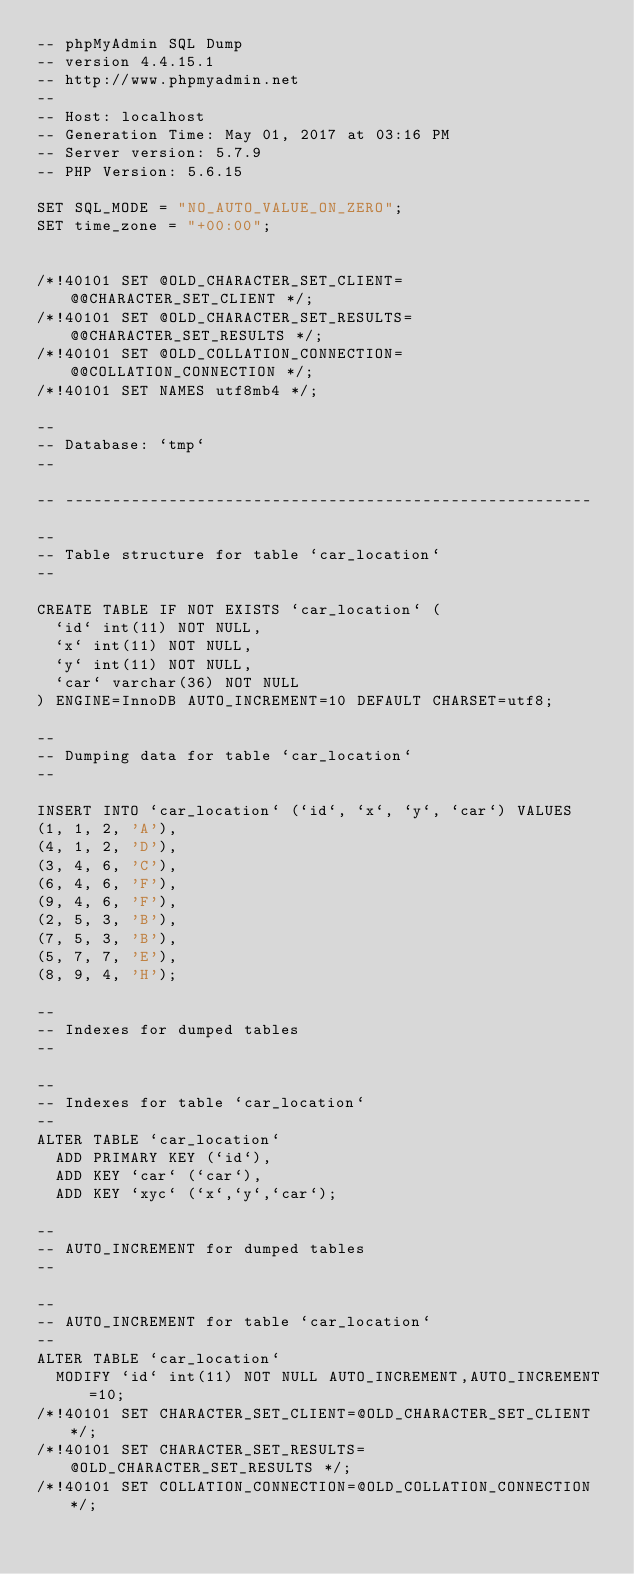<code> <loc_0><loc_0><loc_500><loc_500><_SQL_>-- phpMyAdmin SQL Dump
-- version 4.4.15.1
-- http://www.phpmyadmin.net
--
-- Host: localhost
-- Generation Time: May 01, 2017 at 03:16 PM
-- Server version: 5.7.9
-- PHP Version: 5.6.15

SET SQL_MODE = "NO_AUTO_VALUE_ON_ZERO";
SET time_zone = "+00:00";


/*!40101 SET @OLD_CHARACTER_SET_CLIENT=@@CHARACTER_SET_CLIENT */;
/*!40101 SET @OLD_CHARACTER_SET_RESULTS=@@CHARACTER_SET_RESULTS */;
/*!40101 SET @OLD_COLLATION_CONNECTION=@@COLLATION_CONNECTION */;
/*!40101 SET NAMES utf8mb4 */;

--
-- Database: `tmp`
--

-- --------------------------------------------------------

--
-- Table structure for table `car_location`
--

CREATE TABLE IF NOT EXISTS `car_location` (
  `id` int(11) NOT NULL,
  `x` int(11) NOT NULL,
  `y` int(11) NOT NULL,
  `car` varchar(36) NOT NULL
) ENGINE=InnoDB AUTO_INCREMENT=10 DEFAULT CHARSET=utf8;

--
-- Dumping data for table `car_location`
--

INSERT INTO `car_location` (`id`, `x`, `y`, `car`) VALUES
(1, 1, 2, 'A'),
(4, 1, 2, 'D'),
(3, 4, 6, 'C'),
(6, 4, 6, 'F'),
(9, 4, 6, 'F'),
(2, 5, 3, 'B'),
(7, 5, 3, 'B'),
(5, 7, 7, 'E'),
(8, 9, 4, 'H');

--
-- Indexes for dumped tables
--

--
-- Indexes for table `car_location`
--
ALTER TABLE `car_location`
  ADD PRIMARY KEY (`id`),
  ADD KEY `car` (`car`),
  ADD KEY `xyc` (`x`,`y`,`car`);

--
-- AUTO_INCREMENT for dumped tables
--

--
-- AUTO_INCREMENT for table `car_location`
--
ALTER TABLE `car_location`
  MODIFY `id` int(11) NOT NULL AUTO_INCREMENT,AUTO_INCREMENT=10;
/*!40101 SET CHARACTER_SET_CLIENT=@OLD_CHARACTER_SET_CLIENT */;
/*!40101 SET CHARACTER_SET_RESULTS=@OLD_CHARACTER_SET_RESULTS */;
/*!40101 SET COLLATION_CONNECTION=@OLD_COLLATION_CONNECTION */;
</code> 